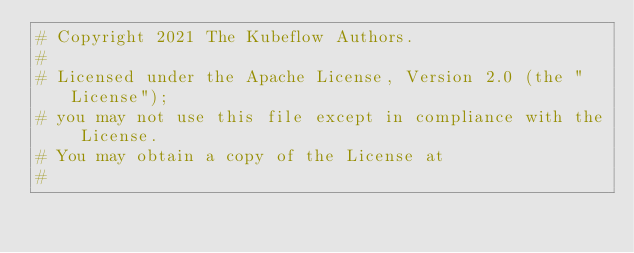<code> <loc_0><loc_0><loc_500><loc_500><_Python_># Copyright 2021 The Kubeflow Authors.
#
# Licensed under the Apache License, Version 2.0 (the "License");
# you may not use this file except in compliance with the License.
# You may obtain a copy of the License at
#</code> 